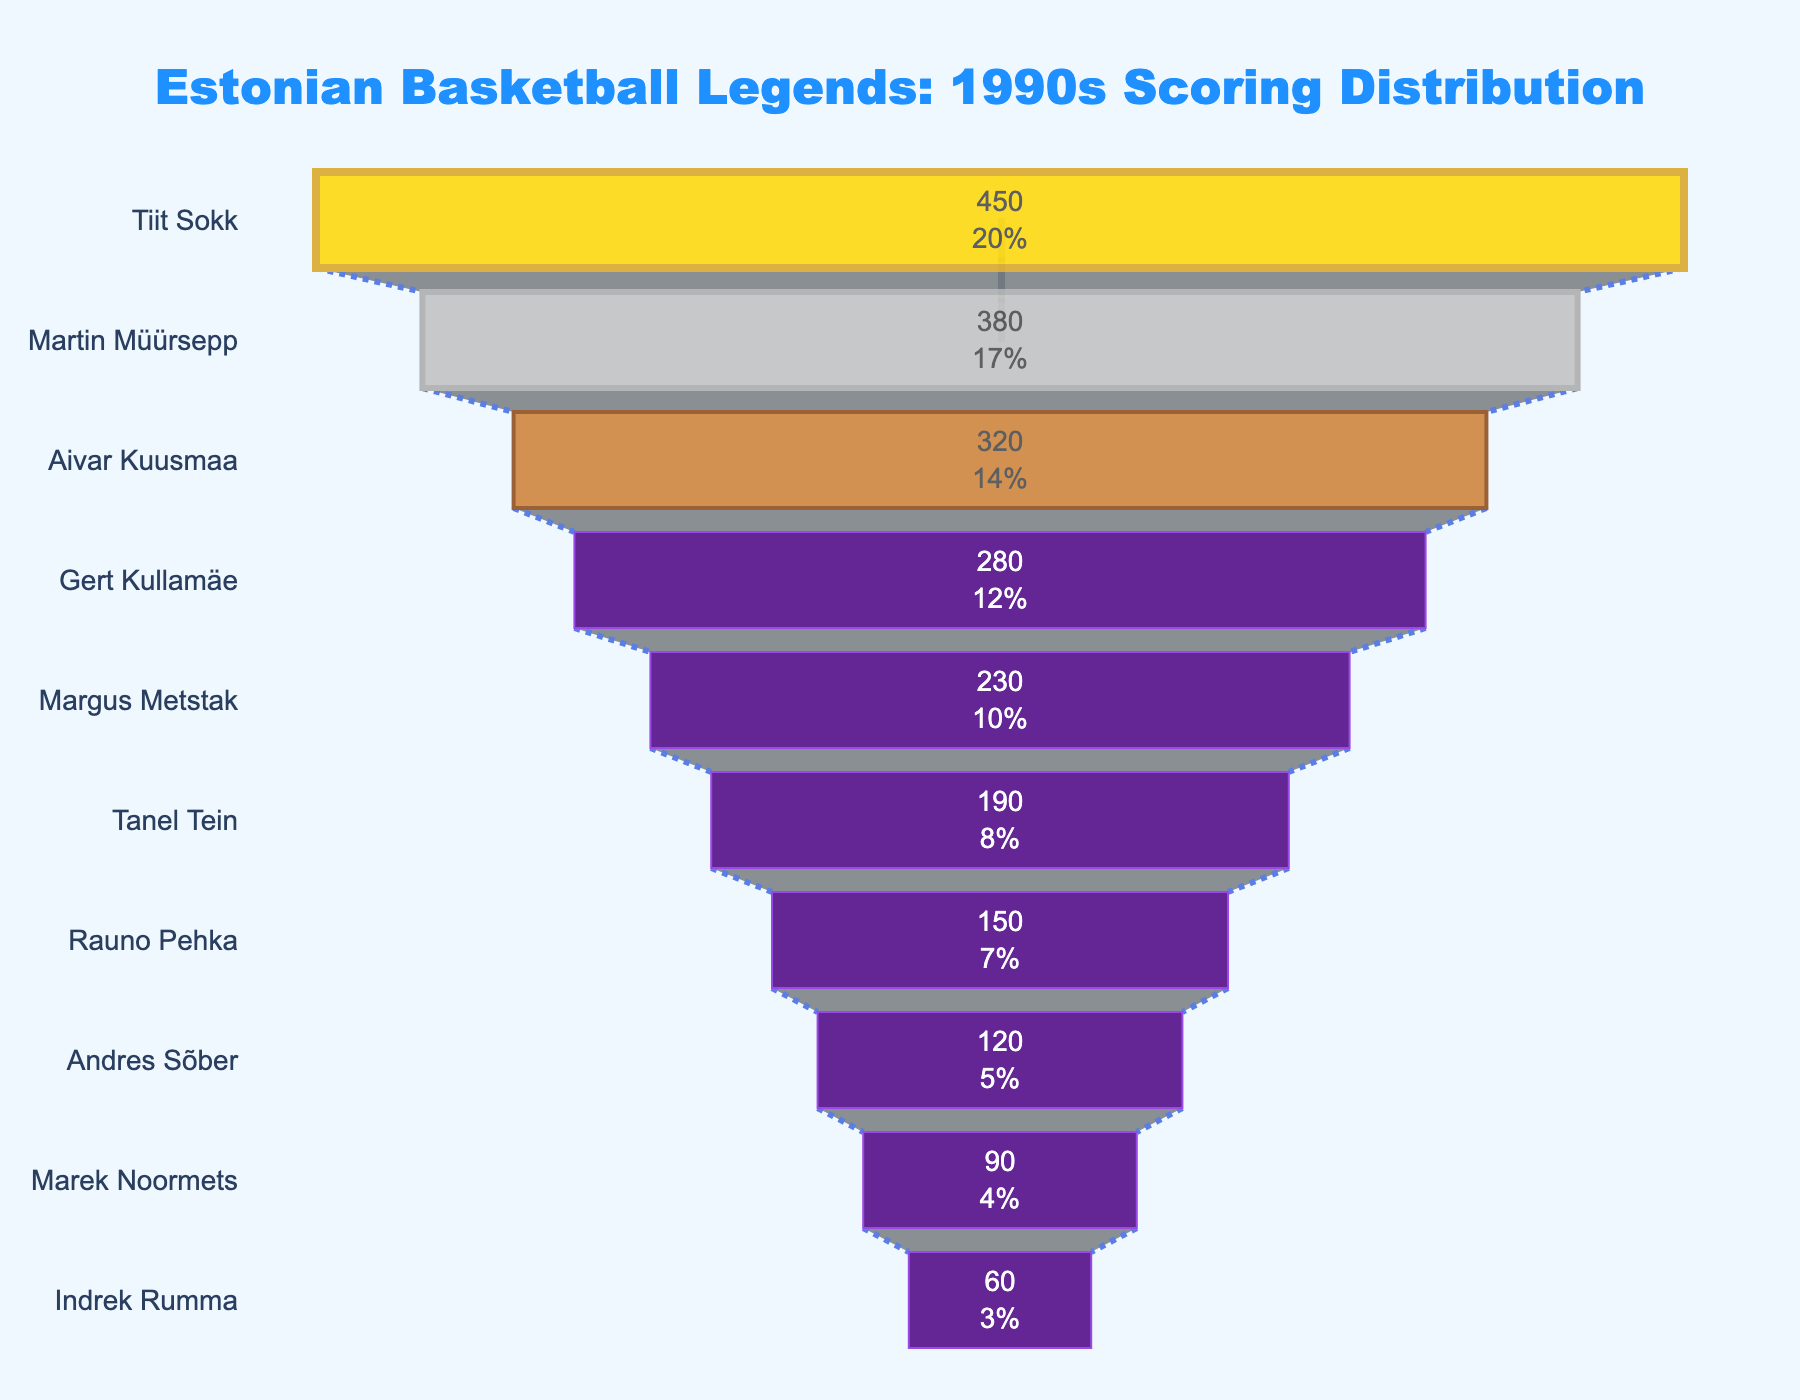Who is the highest-scoring player? The player with the tallest section of the funnel chart is at the top, indicating the highest points. In this case, it is Tiit Sokk with 450 points.
Answer: Tiit Sokk How many points did Martin Müürsepp score? The figure indicates the individual points scored by each player in the funnel sections. Martin Müürsepp scored 380 points.
Answer: 380 Which players are in the top three scoring positions? The top three sections of the funnel chart represent these players based on descending points. They are Tiit Sokk, Martin Müürsepp, and Aivar Kuusmaa.
Answer: Tiit Sokk, Martin Müürsepp, Aivar Kuusmaa Who scored more points, Margus Metstak or Tanel Tein? The funnel chart's sections allow us to visually compare the lengths representing player scores. Margus Metstak scored more with 230 points compared to Tanel Tein's 190 points.
Answer: Margus Metstak What is the combined score of the top three players? The top three players in the funnel chart are Tiit Sokk, Martin Müürsepp, and Aivar Kuusmaa. Adding their points: 450 + 380 + 320 equals 1150.
Answer: 1150 What's the difference in points between Gert Kullamäe and Andres Sõber? Gert Kullamäe scored 280 points while Andres Sõber scored 120 points. The difference is 280 - 120 = 160 points.
Answer: 160 How many players scored more than 200 points? By counting the sections of the funnel chart that are above or equal to 200 points, we find five players (Tiit Sokk, Martin Müürsepp, Aivar Kuusmaa, Gert Kullamäe, and Margus Metstak).
Answer: 5 Which player's points make up the smallest percentage of the total? By observing the smallest section of the funnel chart, Indrek Rumma scored the fewest points, which is 60.
Answer: Indrek Rumma What percentage of the total points did Tiit Sokk score? Tiit Sokk scored 450 points. First, sum all player points: 450 + 380 + 320 + 280 + 230 + 190 + 150 + 120 + 90 + 60 = 2270. Then, calculate the percentage: (450 / 2270) * 100 ≈ 19.82%.
Answer: 19.82% Are more players scoring above or below 200 points? There are more players with scores below 200 points in the funnel chart. Count the players: 5 above and 5 below, so it's equal.
Answer: equal 